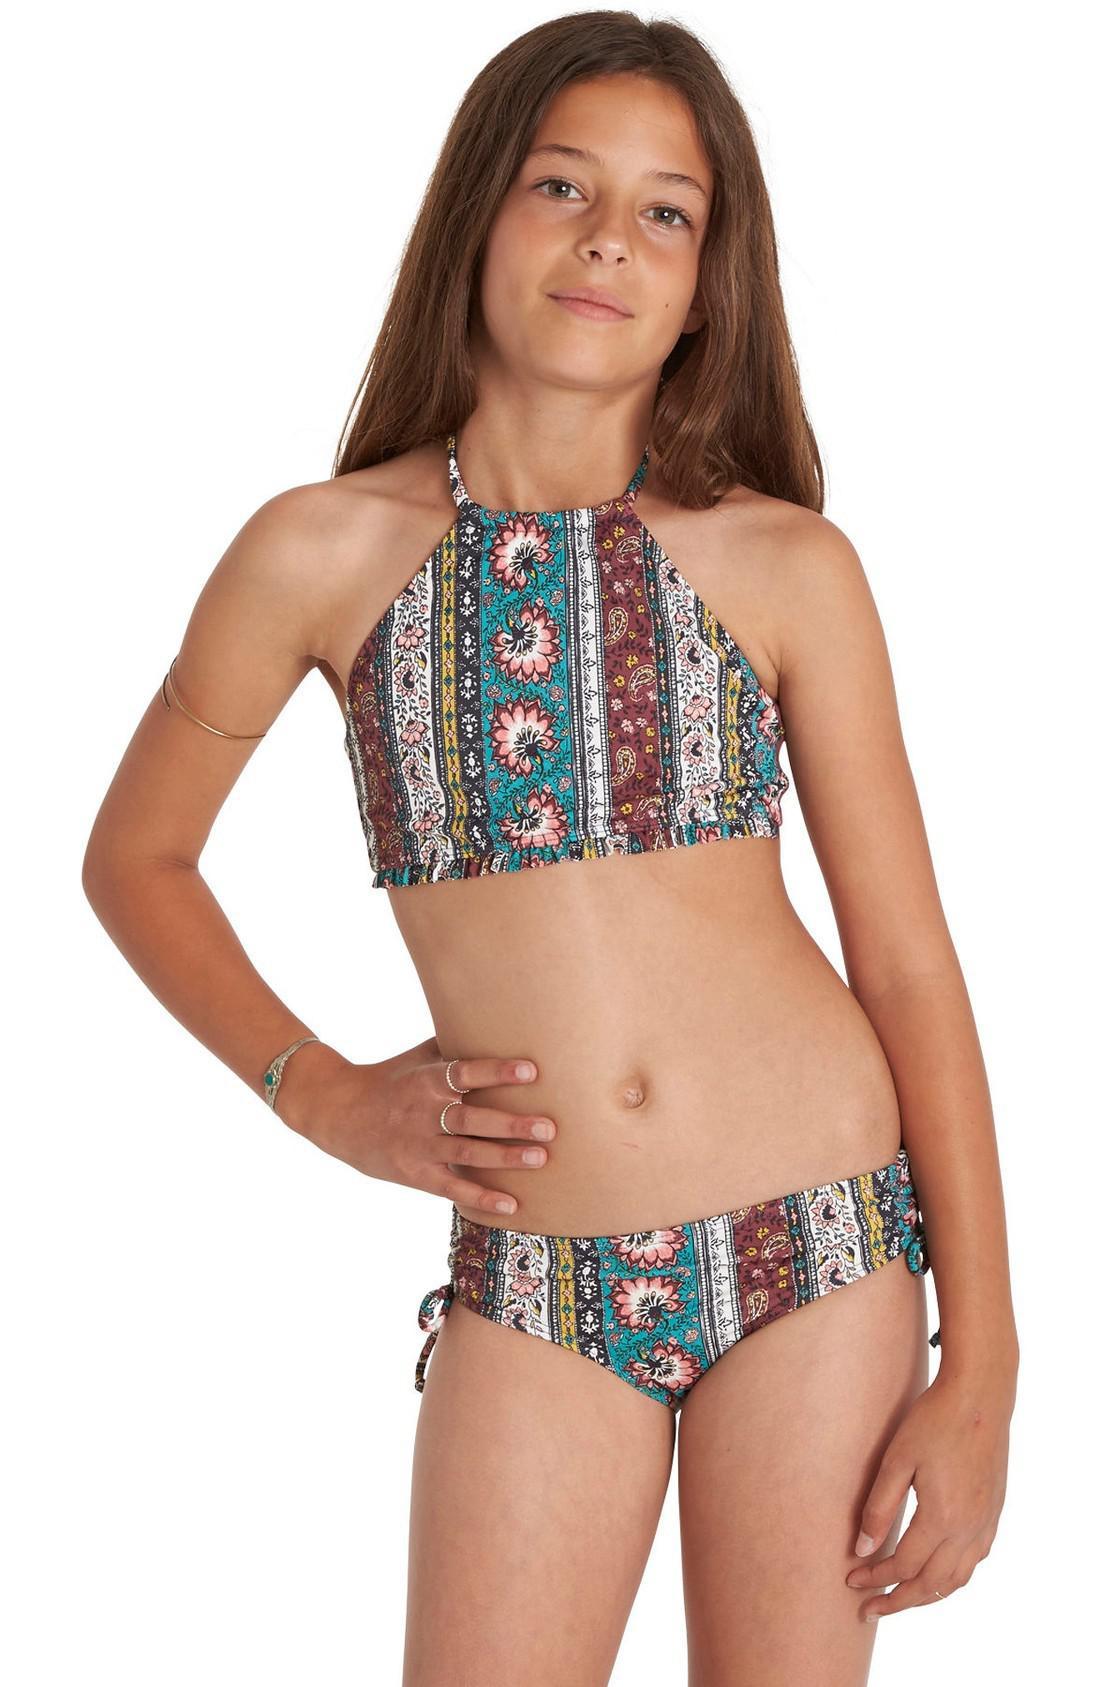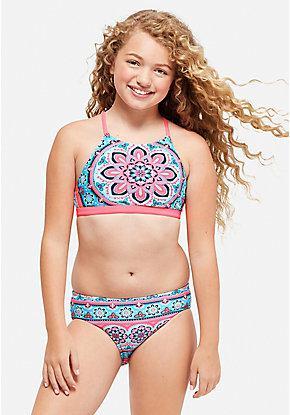The first image is the image on the left, the second image is the image on the right. Analyze the images presented: Is the assertion "the model in the image on the left has her hand on her hip" valid? Answer yes or no. Yes. The first image is the image on the left, the second image is the image on the right. Analyze the images presented: Is the assertion "One bikini is tied with bows." valid? Answer yes or no. No. 